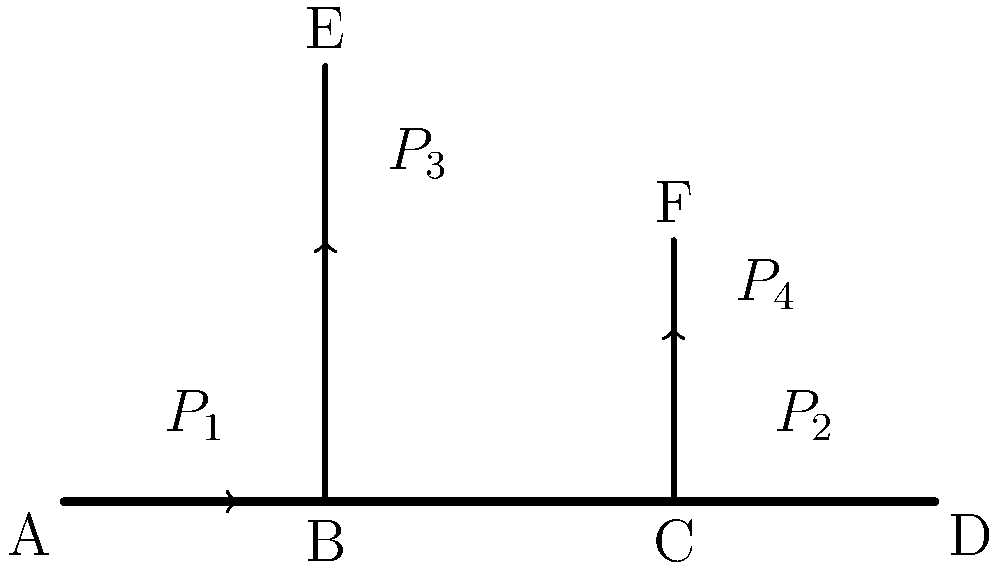In the given pipe network, water flows from point A to points D, E, and F. The main pipe has a diameter of 100mm, while both branch pipes have a diameter of 50mm. If the pressure at point A ($P_1$) is 200 kPa and the pressure at point D ($P_2$) is 180 kPa, estimate the pressures $P_3$ and $P_4$ at points E and F, respectively. Assume steady-state flow and neglect minor losses. How might this analysis be relevant to optimizing resource allocation in an open-source project? To solve this problem, we'll use the concept of pressure drop in pipes and the continuity equation. Let's approach this step-by-step:

1. First, we need to understand that the pressure drop in the main pipe from A to D is 20 kPa (200 kPa - 180 kPa).

2. Assuming the flow is divided equally between the two branches (since they have the same diameter), we can say that each branch receives 1/3 of the total flow.

3. The pressure drop is proportional to the square of the flow rate and inversely proportional to the fifth power of the diameter. We can express this as:

   $$\Delta P \propto \frac{Q^2}{D^5}$$

4. Let's call the flow rate in the main pipe $Q$. Then, the flow rate in each branch is $Q/3$.

5. The ratio of pressure drops between the main pipe and each branch can be expressed as:

   $$\frac{\Delta P_{branch}}{\Delta P_{main}} = \frac{(Q/3)^2 / (50mm)^5}{Q^2 / (100mm)^5} = \frac{1}{9} \cdot 32 = \frac{32}{9}$$

6. Since the pressure drop in the main pipe is 20 kPa, the pressure drop in each branch is:

   $$\Delta P_{branch} = 20 \text{ kPa} \cdot \frac{32}{9} \approx 71.1 \text{ kPa}$$

7. Therefore, the pressures at points E and F are:

   $$P_3 = P_4 = 200 \text{ kPa} - 71.1 \text{ kPa} \approx 128.9 \text{ kPa}$$

This analysis is relevant to optimizing resource allocation in an open-source project as it demonstrates how resources (in this case, water flow and pressure) are distributed through a network. In project management, understanding how to efficiently allocate resources across different branches or components of a project is crucial for optimal performance and delivery.
Answer: $P_3 = P_4 \approx 128.9 \text{ kPa}$ 